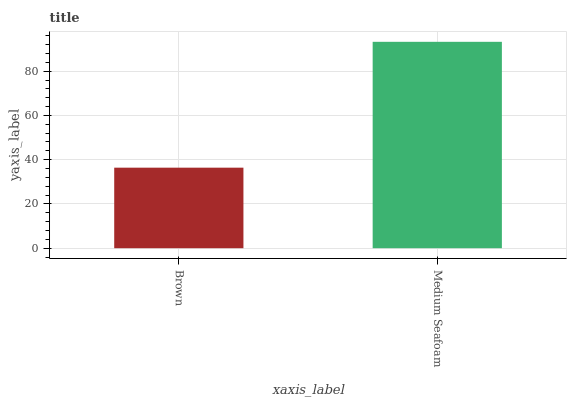Is Brown the minimum?
Answer yes or no. Yes. Is Medium Seafoam the maximum?
Answer yes or no. Yes. Is Medium Seafoam the minimum?
Answer yes or no. No. Is Medium Seafoam greater than Brown?
Answer yes or no. Yes. Is Brown less than Medium Seafoam?
Answer yes or no. Yes. Is Brown greater than Medium Seafoam?
Answer yes or no. No. Is Medium Seafoam less than Brown?
Answer yes or no. No. Is Medium Seafoam the high median?
Answer yes or no. Yes. Is Brown the low median?
Answer yes or no. Yes. Is Brown the high median?
Answer yes or no. No. Is Medium Seafoam the low median?
Answer yes or no. No. 